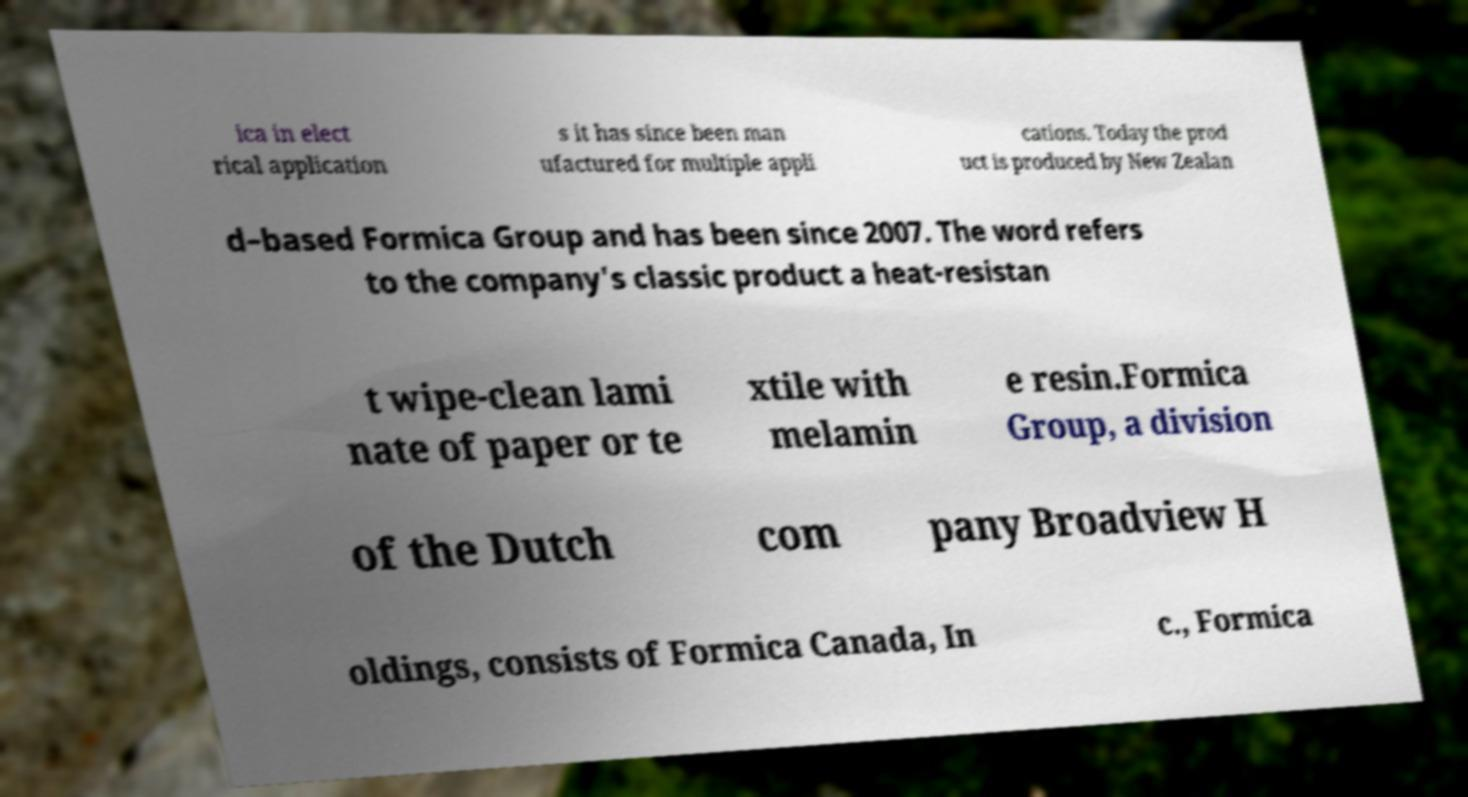Could you extract and type out the text from this image? ica in elect rical application s it has since been man ufactured for multiple appli cations. Today the prod uct is produced by New Zealan d–based Formica Group and has been since 2007. The word refers to the company's classic product a heat-resistan t wipe-clean lami nate of paper or te xtile with melamin e resin.Formica Group, a division of the Dutch com pany Broadview H oldings, consists of Formica Canada, In c., Formica 